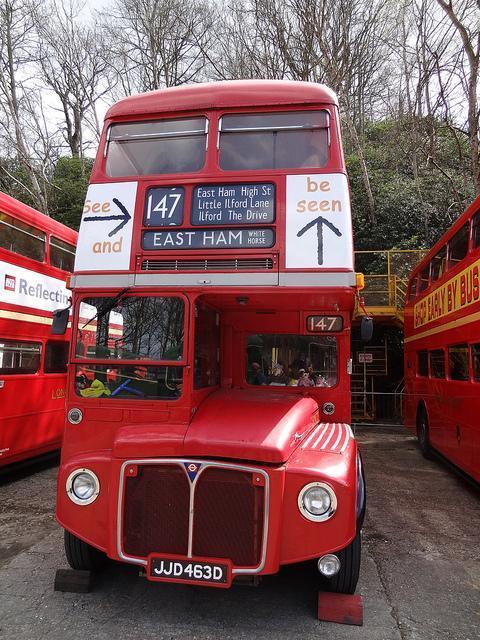How many buses are there?
Give a very brief answer. 3. How many people are holding onto the parachute line?
Give a very brief answer. 0. 